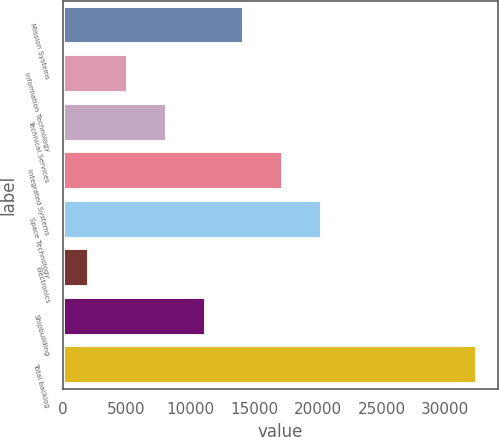Convert chart to OTSL. <chart><loc_0><loc_0><loc_500><loc_500><bar_chart><fcel>Mission Systems<fcel>Information Technology<fcel>Technical Services<fcel>Integrated Systems<fcel>Space Technology<fcel>Electronics<fcel>Shipbuilding<fcel>Total backlog<nl><fcel>14233.8<fcel>5093.7<fcel>8140.4<fcel>17280.5<fcel>20327.2<fcel>2047<fcel>11187.1<fcel>32514<nl></chart> 